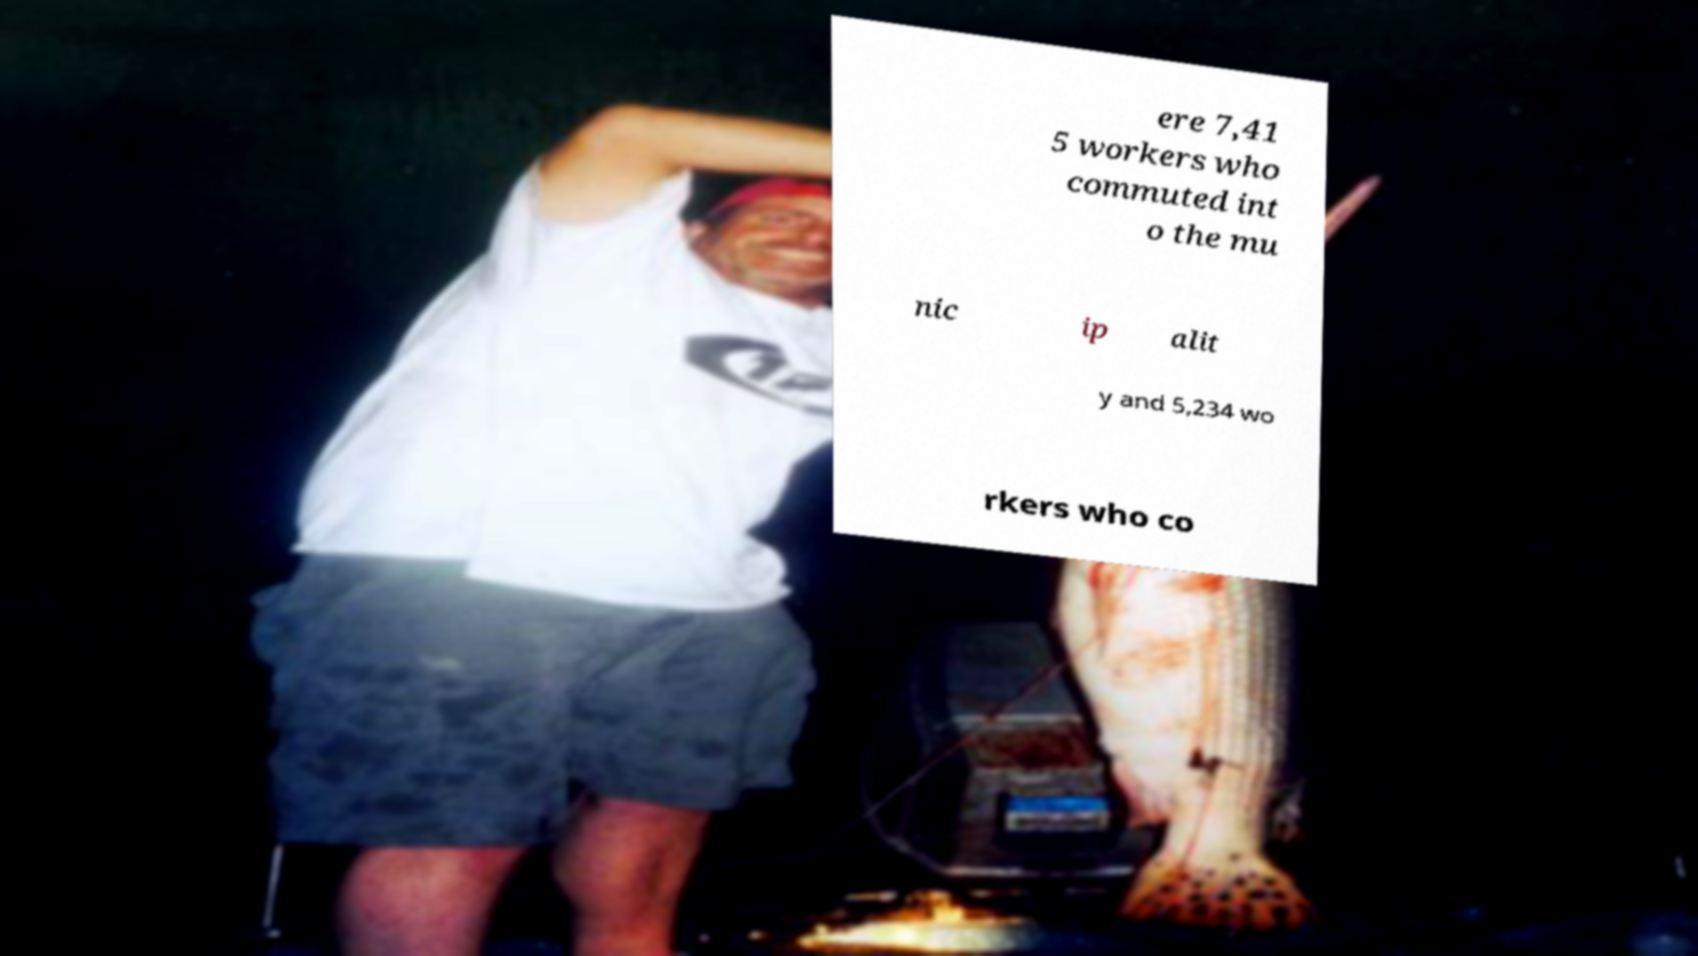Can you accurately transcribe the text from the provided image for me? ere 7,41 5 workers who commuted int o the mu nic ip alit y and 5,234 wo rkers who co 